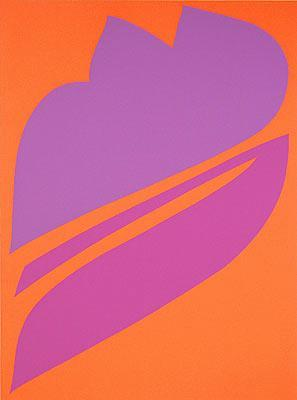What do you think was the artist's inspiration for this piece? The artist may have been inspired by the beauty of nature, evident in the leaf-like shape dominating the center of the canvas. The bold and vibrant color scheme may reflect the artist's interpretation of the natural world's dynamic and lively essence. The abstract form suggests that the artist aimed to capture an essence or feeling rather than a literal representation, inviting viewers to explore their own interpretations and emotions. 